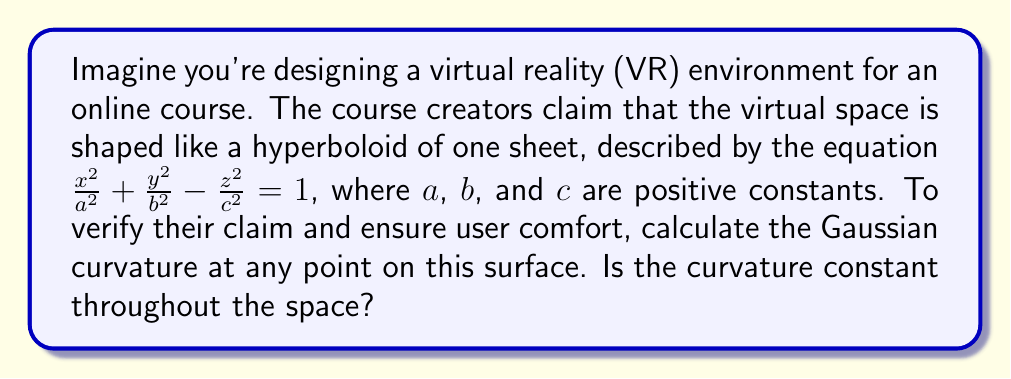Teach me how to tackle this problem. Let's approach this step-by-step:

1) First, we need to parameterize the surface. A common parameterization for a hyperboloid of one sheet is:
   $$x = a\cosh u \cos v, \quad y = b\cosh u \sin v, \quad z = c\sinh u$$
   where $u \in \mathbb{R}$ and $v \in [0, 2\pi)$.

2) To calculate the Gaussian curvature, we need to find the coefficients of the first and second fundamental forms. Let's start with the first fundamental form:

3) Calculate the partial derivatives:
   $$\mathbf{r}_u = (a\sinh u \cos v, b\sinh u \sin v, c\cosh u)$$
   $$\mathbf{r}_v = (-a\cosh u \sin v, b\cosh u \cos v, 0)$$

4) Now we can find E, F, and G:
   $$E = \mathbf{r}_u \cdot \mathbf{r}_u = a^2\sinh^2 u \cos^2 v + b^2\sinh^2 u \sin^2 v + c^2\cosh^2 u$$
   $$F = \mathbf{r}_u \cdot \mathbf{r}_v = (b^2-a^2)\sinh u \cosh u \sin v \cos v$$
   $$G = \mathbf{r}_v \cdot \mathbf{r}_v = a^2\cosh^2 u \sin^2 v + b^2\cosh^2 u \cos^2 v$$

5) For the second fundamental form, we need the unit normal vector:
   $$\mathbf{N} = \frac{\mathbf{r}_u \times \mathbf{r}_v}{|\mathbf{r}_u \times \mathbf{r}_v|}$$

6) Calculate the second partial derivatives:
   $$\mathbf{r}_{uu} = (a\cosh u \cos v, b\cosh u \sin v, c\sinh u)$$
   $$\mathbf{r}_{uv} = (-a\sinh u \sin v, b\sinh u \cos v, 0)$$
   $$\mathbf{r}_{vv} = (-a\cosh u \cos v, -b\cosh u \sin v, 0)$$

7) Now we can find L, M, and N:
   $$L = \mathbf{r}_{uu} \cdot \mathbf{N}$$
   $$M = \mathbf{r}_{uv} \cdot \mathbf{N}$$
   $$N = \mathbf{r}_{vv} \cdot \mathbf{N}$$

8) The Gaussian curvature is given by:
   $$K = \frac{LN - M^2}{EG - F^2}$$

9) After simplification, we get:
   $$K = -\frac{1}{a^2b^2c^2}(a^2\cosh^2 u + b^2\cosh^2 u - c^2\sinh^2 u)^{-2}$$

10) Substitute the original equation of the hyperboloid:
    $$\frac{x^2}{a^2} + \frac{y^2}{b^2} - \frac{z^2}{c^2} = 1$$
    $$\cosh^2 u \cos^2 v + \cosh^2 u \sin^2 v - \sinh^2 u = 1$$
    $$\cosh^2 u - \sinh^2 u = 1$$

11) This simplifies our curvature to:
    $$K = -\frac{1}{a^2b^2c^2}$$

This result is constant and negative, confirming that the surface is indeed a hyperboloid of one sheet with constant negative curvature.
Answer: $K = -\frac{1}{a^2b^2c^2}$ 